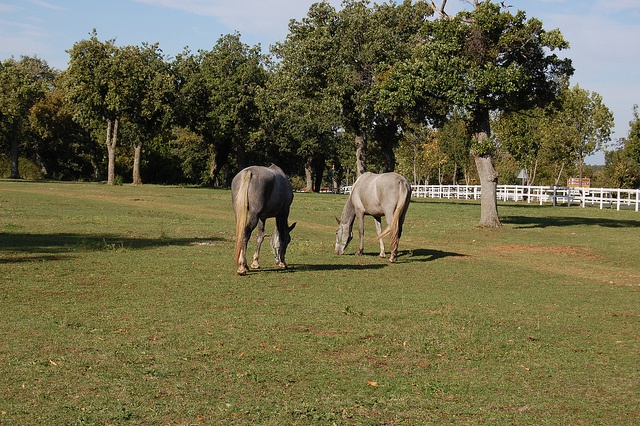Describe the objects in this image and their specific colors. I can see horse in lightblue, black, gray, and tan tones and horse in lightblue, tan, and gray tones in this image. 